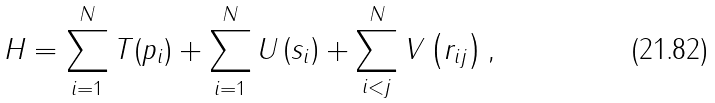Convert formula to latex. <formula><loc_0><loc_0><loc_500><loc_500>H = \sum _ { i = 1 } ^ { N } T ( p _ { i } ) + \sum _ { i = 1 } ^ { N } U \left ( s _ { i } \right ) + \sum _ { i < j } ^ { N } V \left ( r _ { i j } \right ) ,</formula> 